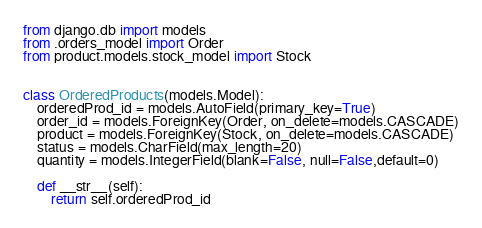<code> <loc_0><loc_0><loc_500><loc_500><_Python_>from django.db import models
from .orders_model import Order
from product.models.stock_model import Stock


class OrderedProducts(models.Model):
    orderedProd_id = models.AutoField(primary_key=True)
    order_id = models.ForeignKey(Order, on_delete=models.CASCADE)
    product = models.ForeignKey(Stock, on_delete=models.CASCADE)
    status = models.CharField(max_length=20)
    quantity = models.IntegerField(blank=False, null=False,default=0)

    def __str__(self):
        return self.orderedProd_id

</code> 